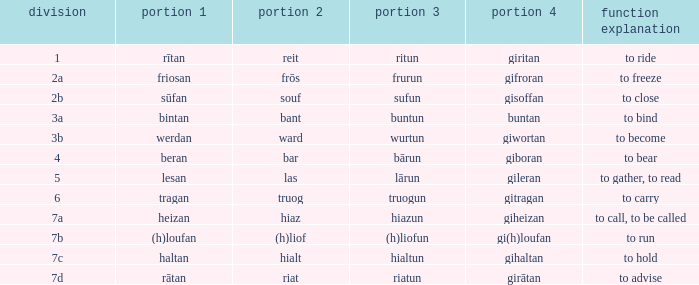Would you be able to parse every entry in this table? {'header': ['division', 'portion 1', 'portion 2', 'portion 3', 'portion 4', 'function explanation'], 'rows': [['1', 'rītan', 'reit', 'ritun', 'giritan', 'to ride'], ['2a', 'friosan', 'frōs', 'frurun', 'gifroran', 'to freeze'], ['2b', 'sūfan', 'souf', 'sufun', 'gisoffan', 'to close'], ['3a', 'bintan', 'bant', 'buntun', 'buntan', 'to bind'], ['3b', 'werdan', 'ward', 'wurtun', 'giwortan', 'to become'], ['4', 'beran', 'bar', 'bārun', 'giboran', 'to bear'], ['5', 'lesan', 'las', 'lārun', 'gileran', 'to gather, to read'], ['6', 'tragan', 'truog', 'truogun', 'gitragan', 'to carry'], ['7a', 'heizan', 'hiaz', 'hiazun', 'giheizan', 'to call, to be called'], ['7b', '(h)loufan', '(h)liof', '(h)liofun', 'gi(h)loufan', 'to run'], ['7c', 'haltan', 'hialt', 'hialtun', 'gihaltan', 'to hold'], ['7d', 'rātan', 'riat', 'riatun', 'girātan', 'to advise']]} What is the part 3 of the word in class 7a? Hiazun. 